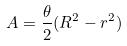<formula> <loc_0><loc_0><loc_500><loc_500>A = \frac { \theta } { 2 } ( R ^ { 2 } - r ^ { 2 } )</formula> 